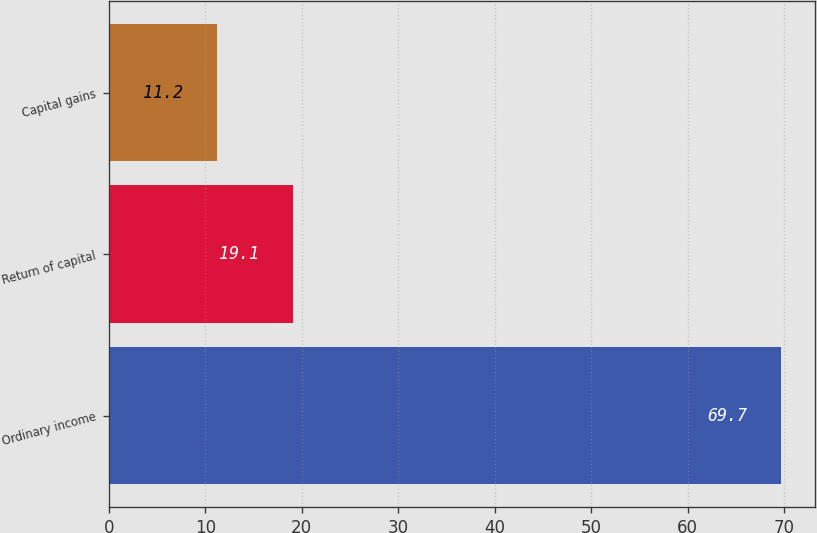<chart> <loc_0><loc_0><loc_500><loc_500><bar_chart><fcel>Ordinary income<fcel>Return of capital<fcel>Capital gains<nl><fcel>69.7<fcel>19.1<fcel>11.2<nl></chart> 